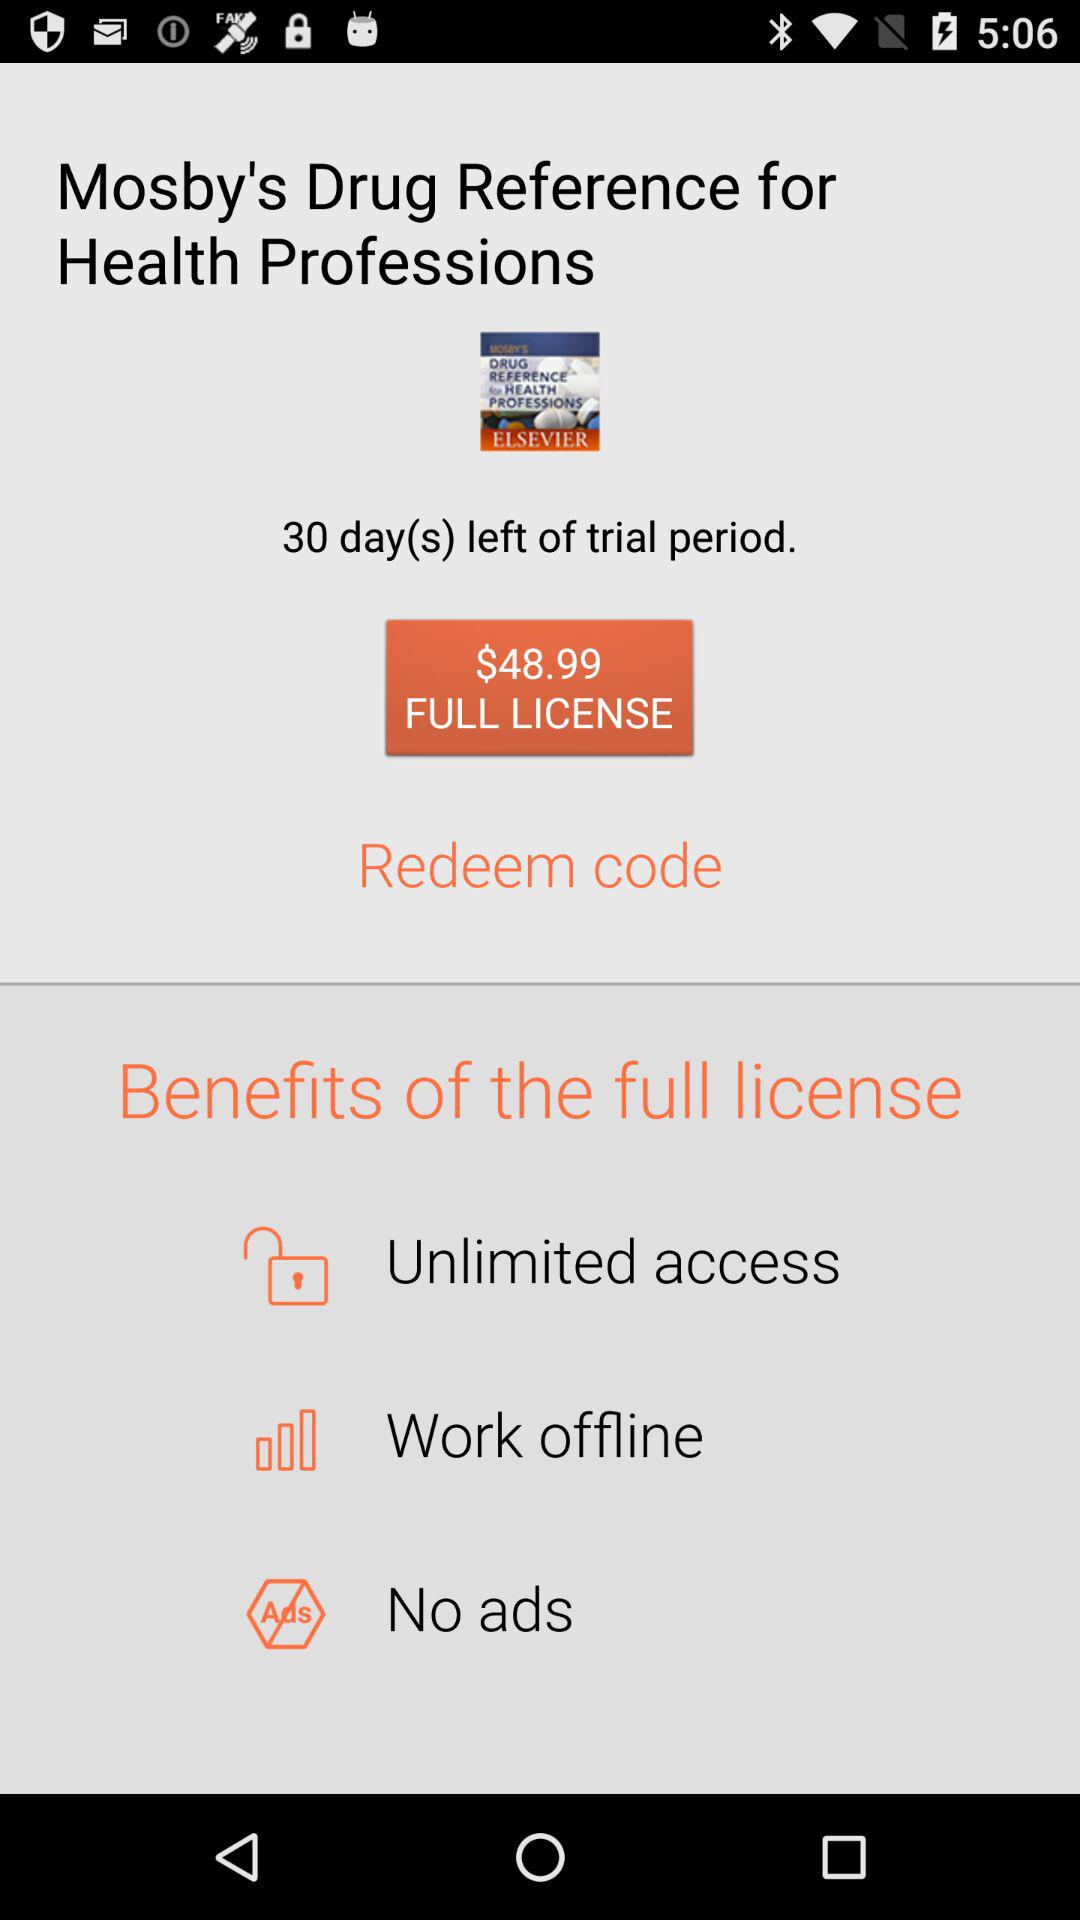What will you get if you buy a full license? You will get "Unlimited access", "Work offline" and "No ads". 